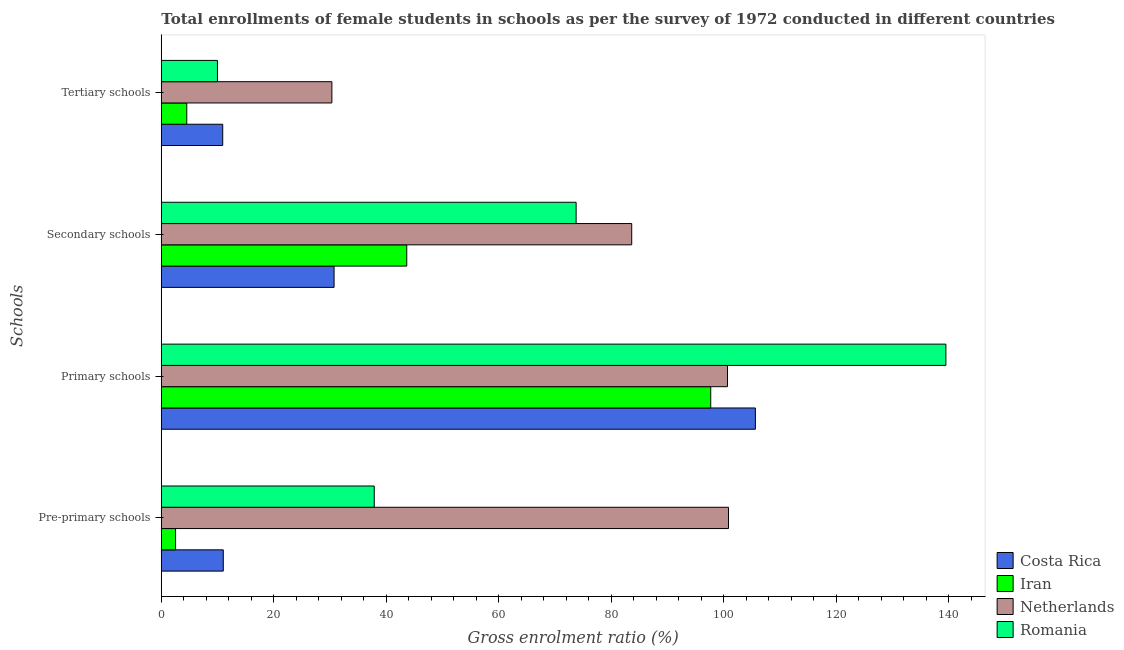How many groups of bars are there?
Your answer should be compact. 4. Are the number of bars per tick equal to the number of legend labels?
Offer a very short reply. Yes. How many bars are there on the 4th tick from the bottom?
Keep it short and to the point. 4. What is the label of the 2nd group of bars from the top?
Make the answer very short. Secondary schools. What is the gross enrolment ratio(female) in pre-primary schools in Romania?
Offer a terse response. 37.86. Across all countries, what is the maximum gross enrolment ratio(female) in tertiary schools?
Offer a terse response. 30.33. Across all countries, what is the minimum gross enrolment ratio(female) in tertiary schools?
Provide a succinct answer. 4.53. In which country was the gross enrolment ratio(female) in secondary schools maximum?
Keep it short and to the point. Netherlands. In which country was the gross enrolment ratio(female) in tertiary schools minimum?
Your answer should be very brief. Iran. What is the total gross enrolment ratio(female) in tertiary schools in the graph?
Your response must be concise. 55.75. What is the difference between the gross enrolment ratio(female) in tertiary schools in Romania and that in Iran?
Ensure brevity in your answer.  5.46. What is the difference between the gross enrolment ratio(female) in primary schools in Romania and the gross enrolment ratio(female) in secondary schools in Netherlands?
Your answer should be compact. 55.86. What is the average gross enrolment ratio(female) in pre-primary schools per country?
Your answer should be compact. 38.06. What is the difference between the gross enrolment ratio(female) in secondary schools and gross enrolment ratio(female) in tertiary schools in Iran?
Offer a very short reply. 39.11. In how many countries, is the gross enrolment ratio(female) in primary schools greater than 112 %?
Offer a very short reply. 1. What is the ratio of the gross enrolment ratio(female) in secondary schools in Romania to that in Costa Rica?
Provide a succinct answer. 2.4. Is the gross enrolment ratio(female) in primary schools in Iran less than that in Romania?
Provide a short and direct response. Yes. Is the difference between the gross enrolment ratio(female) in pre-primary schools in Costa Rica and Romania greater than the difference between the gross enrolment ratio(female) in primary schools in Costa Rica and Romania?
Offer a terse response. Yes. What is the difference between the highest and the second highest gross enrolment ratio(female) in primary schools?
Your response must be concise. 33.87. What is the difference between the highest and the lowest gross enrolment ratio(female) in primary schools?
Offer a very short reply. 41.81. Is the sum of the gross enrolment ratio(female) in secondary schools in Costa Rica and Romania greater than the maximum gross enrolment ratio(female) in tertiary schools across all countries?
Offer a very short reply. Yes. Is it the case that in every country, the sum of the gross enrolment ratio(female) in tertiary schools and gross enrolment ratio(female) in pre-primary schools is greater than the sum of gross enrolment ratio(female) in secondary schools and gross enrolment ratio(female) in primary schools?
Keep it short and to the point. No. Is it the case that in every country, the sum of the gross enrolment ratio(female) in pre-primary schools and gross enrolment ratio(female) in primary schools is greater than the gross enrolment ratio(female) in secondary schools?
Your response must be concise. Yes. Are all the bars in the graph horizontal?
Provide a succinct answer. Yes. What is the difference between two consecutive major ticks on the X-axis?
Your answer should be very brief. 20. Does the graph contain grids?
Your response must be concise. No. Where does the legend appear in the graph?
Offer a very short reply. Bottom right. What is the title of the graph?
Offer a terse response. Total enrollments of female students in schools as per the survey of 1972 conducted in different countries. What is the label or title of the Y-axis?
Your response must be concise. Schools. What is the Gross enrolment ratio (%) in Costa Rica in Pre-primary schools?
Offer a terse response. 11.02. What is the Gross enrolment ratio (%) in Iran in Pre-primary schools?
Your answer should be very brief. 2.53. What is the Gross enrolment ratio (%) in Netherlands in Pre-primary schools?
Offer a very short reply. 100.85. What is the Gross enrolment ratio (%) of Romania in Pre-primary schools?
Ensure brevity in your answer.  37.86. What is the Gross enrolment ratio (%) of Costa Rica in Primary schools?
Your response must be concise. 105.63. What is the Gross enrolment ratio (%) of Iran in Primary schools?
Your response must be concise. 97.69. What is the Gross enrolment ratio (%) of Netherlands in Primary schools?
Keep it short and to the point. 100.67. What is the Gross enrolment ratio (%) in Romania in Primary schools?
Offer a terse response. 139.5. What is the Gross enrolment ratio (%) of Costa Rica in Secondary schools?
Keep it short and to the point. 30.72. What is the Gross enrolment ratio (%) in Iran in Secondary schools?
Provide a succinct answer. 43.64. What is the Gross enrolment ratio (%) of Netherlands in Secondary schools?
Keep it short and to the point. 83.64. What is the Gross enrolment ratio (%) of Romania in Secondary schools?
Your response must be concise. 73.75. What is the Gross enrolment ratio (%) in Costa Rica in Tertiary schools?
Your response must be concise. 10.92. What is the Gross enrolment ratio (%) in Iran in Tertiary schools?
Provide a short and direct response. 4.53. What is the Gross enrolment ratio (%) of Netherlands in Tertiary schools?
Provide a succinct answer. 30.33. What is the Gross enrolment ratio (%) of Romania in Tertiary schools?
Give a very brief answer. 9.98. Across all Schools, what is the maximum Gross enrolment ratio (%) of Costa Rica?
Offer a very short reply. 105.63. Across all Schools, what is the maximum Gross enrolment ratio (%) of Iran?
Ensure brevity in your answer.  97.69. Across all Schools, what is the maximum Gross enrolment ratio (%) in Netherlands?
Your answer should be very brief. 100.85. Across all Schools, what is the maximum Gross enrolment ratio (%) of Romania?
Provide a short and direct response. 139.5. Across all Schools, what is the minimum Gross enrolment ratio (%) in Costa Rica?
Give a very brief answer. 10.92. Across all Schools, what is the minimum Gross enrolment ratio (%) of Iran?
Provide a succinct answer. 2.53. Across all Schools, what is the minimum Gross enrolment ratio (%) in Netherlands?
Keep it short and to the point. 30.33. Across all Schools, what is the minimum Gross enrolment ratio (%) of Romania?
Your response must be concise. 9.98. What is the total Gross enrolment ratio (%) in Costa Rica in the graph?
Your response must be concise. 158.28. What is the total Gross enrolment ratio (%) in Iran in the graph?
Your response must be concise. 148.39. What is the total Gross enrolment ratio (%) of Netherlands in the graph?
Your answer should be very brief. 315.48. What is the total Gross enrolment ratio (%) of Romania in the graph?
Offer a very short reply. 261.09. What is the difference between the Gross enrolment ratio (%) in Costa Rica in Pre-primary schools and that in Primary schools?
Provide a short and direct response. -94.61. What is the difference between the Gross enrolment ratio (%) of Iran in Pre-primary schools and that in Primary schools?
Keep it short and to the point. -95.16. What is the difference between the Gross enrolment ratio (%) in Netherlands in Pre-primary schools and that in Primary schools?
Offer a terse response. 0.18. What is the difference between the Gross enrolment ratio (%) in Romania in Pre-primary schools and that in Primary schools?
Give a very brief answer. -101.64. What is the difference between the Gross enrolment ratio (%) in Costa Rica in Pre-primary schools and that in Secondary schools?
Keep it short and to the point. -19.7. What is the difference between the Gross enrolment ratio (%) in Iran in Pre-primary schools and that in Secondary schools?
Offer a terse response. -41.11. What is the difference between the Gross enrolment ratio (%) of Netherlands in Pre-primary schools and that in Secondary schools?
Your answer should be compact. 17.21. What is the difference between the Gross enrolment ratio (%) in Romania in Pre-primary schools and that in Secondary schools?
Keep it short and to the point. -35.89. What is the difference between the Gross enrolment ratio (%) in Costa Rica in Pre-primary schools and that in Tertiary schools?
Ensure brevity in your answer.  0.1. What is the difference between the Gross enrolment ratio (%) in Iran in Pre-primary schools and that in Tertiary schools?
Your answer should be very brief. -1.99. What is the difference between the Gross enrolment ratio (%) of Netherlands in Pre-primary schools and that in Tertiary schools?
Offer a very short reply. 70.52. What is the difference between the Gross enrolment ratio (%) of Romania in Pre-primary schools and that in Tertiary schools?
Provide a succinct answer. 27.88. What is the difference between the Gross enrolment ratio (%) in Costa Rica in Primary schools and that in Secondary schools?
Offer a terse response. 74.91. What is the difference between the Gross enrolment ratio (%) in Iran in Primary schools and that in Secondary schools?
Your response must be concise. 54.05. What is the difference between the Gross enrolment ratio (%) in Netherlands in Primary schools and that in Secondary schools?
Provide a short and direct response. 17.03. What is the difference between the Gross enrolment ratio (%) of Romania in Primary schools and that in Secondary schools?
Give a very brief answer. 65.75. What is the difference between the Gross enrolment ratio (%) in Costa Rica in Primary schools and that in Tertiary schools?
Provide a succinct answer. 94.71. What is the difference between the Gross enrolment ratio (%) in Iran in Primary schools and that in Tertiary schools?
Ensure brevity in your answer.  93.16. What is the difference between the Gross enrolment ratio (%) in Netherlands in Primary schools and that in Tertiary schools?
Your response must be concise. 70.34. What is the difference between the Gross enrolment ratio (%) in Romania in Primary schools and that in Tertiary schools?
Keep it short and to the point. 129.52. What is the difference between the Gross enrolment ratio (%) of Costa Rica in Secondary schools and that in Tertiary schools?
Provide a succinct answer. 19.8. What is the difference between the Gross enrolment ratio (%) in Iran in Secondary schools and that in Tertiary schools?
Give a very brief answer. 39.11. What is the difference between the Gross enrolment ratio (%) of Netherlands in Secondary schools and that in Tertiary schools?
Give a very brief answer. 53.31. What is the difference between the Gross enrolment ratio (%) of Romania in Secondary schools and that in Tertiary schools?
Make the answer very short. 63.77. What is the difference between the Gross enrolment ratio (%) in Costa Rica in Pre-primary schools and the Gross enrolment ratio (%) in Iran in Primary schools?
Ensure brevity in your answer.  -86.67. What is the difference between the Gross enrolment ratio (%) in Costa Rica in Pre-primary schools and the Gross enrolment ratio (%) in Netherlands in Primary schools?
Your response must be concise. -89.65. What is the difference between the Gross enrolment ratio (%) of Costa Rica in Pre-primary schools and the Gross enrolment ratio (%) of Romania in Primary schools?
Provide a succinct answer. -128.48. What is the difference between the Gross enrolment ratio (%) in Iran in Pre-primary schools and the Gross enrolment ratio (%) in Netherlands in Primary schools?
Keep it short and to the point. -98.14. What is the difference between the Gross enrolment ratio (%) of Iran in Pre-primary schools and the Gross enrolment ratio (%) of Romania in Primary schools?
Ensure brevity in your answer.  -136.97. What is the difference between the Gross enrolment ratio (%) in Netherlands in Pre-primary schools and the Gross enrolment ratio (%) in Romania in Primary schools?
Give a very brief answer. -38.65. What is the difference between the Gross enrolment ratio (%) in Costa Rica in Pre-primary schools and the Gross enrolment ratio (%) in Iran in Secondary schools?
Ensure brevity in your answer.  -32.62. What is the difference between the Gross enrolment ratio (%) of Costa Rica in Pre-primary schools and the Gross enrolment ratio (%) of Netherlands in Secondary schools?
Give a very brief answer. -72.62. What is the difference between the Gross enrolment ratio (%) of Costa Rica in Pre-primary schools and the Gross enrolment ratio (%) of Romania in Secondary schools?
Provide a succinct answer. -62.74. What is the difference between the Gross enrolment ratio (%) in Iran in Pre-primary schools and the Gross enrolment ratio (%) in Netherlands in Secondary schools?
Provide a succinct answer. -81.11. What is the difference between the Gross enrolment ratio (%) of Iran in Pre-primary schools and the Gross enrolment ratio (%) of Romania in Secondary schools?
Provide a succinct answer. -71.22. What is the difference between the Gross enrolment ratio (%) in Netherlands in Pre-primary schools and the Gross enrolment ratio (%) in Romania in Secondary schools?
Your answer should be compact. 27.09. What is the difference between the Gross enrolment ratio (%) in Costa Rica in Pre-primary schools and the Gross enrolment ratio (%) in Iran in Tertiary schools?
Offer a terse response. 6.49. What is the difference between the Gross enrolment ratio (%) in Costa Rica in Pre-primary schools and the Gross enrolment ratio (%) in Netherlands in Tertiary schools?
Provide a short and direct response. -19.31. What is the difference between the Gross enrolment ratio (%) in Costa Rica in Pre-primary schools and the Gross enrolment ratio (%) in Romania in Tertiary schools?
Keep it short and to the point. 1.04. What is the difference between the Gross enrolment ratio (%) of Iran in Pre-primary schools and the Gross enrolment ratio (%) of Netherlands in Tertiary schools?
Your answer should be very brief. -27.8. What is the difference between the Gross enrolment ratio (%) of Iran in Pre-primary schools and the Gross enrolment ratio (%) of Romania in Tertiary schools?
Offer a terse response. -7.45. What is the difference between the Gross enrolment ratio (%) in Netherlands in Pre-primary schools and the Gross enrolment ratio (%) in Romania in Tertiary schools?
Your answer should be compact. 90.86. What is the difference between the Gross enrolment ratio (%) in Costa Rica in Primary schools and the Gross enrolment ratio (%) in Iran in Secondary schools?
Your response must be concise. 61.99. What is the difference between the Gross enrolment ratio (%) of Costa Rica in Primary schools and the Gross enrolment ratio (%) of Netherlands in Secondary schools?
Make the answer very short. 21.99. What is the difference between the Gross enrolment ratio (%) in Costa Rica in Primary schools and the Gross enrolment ratio (%) in Romania in Secondary schools?
Provide a short and direct response. 31.87. What is the difference between the Gross enrolment ratio (%) in Iran in Primary schools and the Gross enrolment ratio (%) in Netherlands in Secondary schools?
Offer a terse response. 14.05. What is the difference between the Gross enrolment ratio (%) of Iran in Primary schools and the Gross enrolment ratio (%) of Romania in Secondary schools?
Your answer should be compact. 23.94. What is the difference between the Gross enrolment ratio (%) in Netherlands in Primary schools and the Gross enrolment ratio (%) in Romania in Secondary schools?
Provide a short and direct response. 26.91. What is the difference between the Gross enrolment ratio (%) of Costa Rica in Primary schools and the Gross enrolment ratio (%) of Iran in Tertiary schools?
Your response must be concise. 101.1. What is the difference between the Gross enrolment ratio (%) of Costa Rica in Primary schools and the Gross enrolment ratio (%) of Netherlands in Tertiary schools?
Your answer should be compact. 75.3. What is the difference between the Gross enrolment ratio (%) of Costa Rica in Primary schools and the Gross enrolment ratio (%) of Romania in Tertiary schools?
Your answer should be very brief. 95.65. What is the difference between the Gross enrolment ratio (%) of Iran in Primary schools and the Gross enrolment ratio (%) of Netherlands in Tertiary schools?
Give a very brief answer. 67.36. What is the difference between the Gross enrolment ratio (%) in Iran in Primary schools and the Gross enrolment ratio (%) in Romania in Tertiary schools?
Ensure brevity in your answer.  87.71. What is the difference between the Gross enrolment ratio (%) of Netherlands in Primary schools and the Gross enrolment ratio (%) of Romania in Tertiary schools?
Your response must be concise. 90.69. What is the difference between the Gross enrolment ratio (%) in Costa Rica in Secondary schools and the Gross enrolment ratio (%) in Iran in Tertiary schools?
Keep it short and to the point. 26.19. What is the difference between the Gross enrolment ratio (%) in Costa Rica in Secondary schools and the Gross enrolment ratio (%) in Netherlands in Tertiary schools?
Ensure brevity in your answer.  0.39. What is the difference between the Gross enrolment ratio (%) of Costa Rica in Secondary schools and the Gross enrolment ratio (%) of Romania in Tertiary schools?
Your answer should be very brief. 20.74. What is the difference between the Gross enrolment ratio (%) of Iran in Secondary schools and the Gross enrolment ratio (%) of Netherlands in Tertiary schools?
Offer a very short reply. 13.31. What is the difference between the Gross enrolment ratio (%) of Iran in Secondary schools and the Gross enrolment ratio (%) of Romania in Tertiary schools?
Your answer should be compact. 33.66. What is the difference between the Gross enrolment ratio (%) in Netherlands in Secondary schools and the Gross enrolment ratio (%) in Romania in Tertiary schools?
Your answer should be very brief. 73.66. What is the average Gross enrolment ratio (%) in Costa Rica per Schools?
Provide a short and direct response. 39.57. What is the average Gross enrolment ratio (%) of Iran per Schools?
Offer a terse response. 37.1. What is the average Gross enrolment ratio (%) of Netherlands per Schools?
Provide a short and direct response. 78.87. What is the average Gross enrolment ratio (%) of Romania per Schools?
Provide a short and direct response. 65.27. What is the difference between the Gross enrolment ratio (%) of Costa Rica and Gross enrolment ratio (%) of Iran in Pre-primary schools?
Give a very brief answer. 8.49. What is the difference between the Gross enrolment ratio (%) of Costa Rica and Gross enrolment ratio (%) of Netherlands in Pre-primary schools?
Keep it short and to the point. -89.83. What is the difference between the Gross enrolment ratio (%) of Costa Rica and Gross enrolment ratio (%) of Romania in Pre-primary schools?
Offer a very short reply. -26.84. What is the difference between the Gross enrolment ratio (%) in Iran and Gross enrolment ratio (%) in Netherlands in Pre-primary schools?
Your answer should be very brief. -98.32. What is the difference between the Gross enrolment ratio (%) of Iran and Gross enrolment ratio (%) of Romania in Pre-primary schools?
Offer a terse response. -35.33. What is the difference between the Gross enrolment ratio (%) of Netherlands and Gross enrolment ratio (%) of Romania in Pre-primary schools?
Your response must be concise. 62.99. What is the difference between the Gross enrolment ratio (%) in Costa Rica and Gross enrolment ratio (%) in Iran in Primary schools?
Make the answer very short. 7.94. What is the difference between the Gross enrolment ratio (%) in Costa Rica and Gross enrolment ratio (%) in Netherlands in Primary schools?
Make the answer very short. 4.96. What is the difference between the Gross enrolment ratio (%) in Costa Rica and Gross enrolment ratio (%) in Romania in Primary schools?
Offer a terse response. -33.87. What is the difference between the Gross enrolment ratio (%) of Iran and Gross enrolment ratio (%) of Netherlands in Primary schools?
Provide a succinct answer. -2.98. What is the difference between the Gross enrolment ratio (%) in Iran and Gross enrolment ratio (%) in Romania in Primary schools?
Your response must be concise. -41.81. What is the difference between the Gross enrolment ratio (%) in Netherlands and Gross enrolment ratio (%) in Romania in Primary schools?
Make the answer very short. -38.83. What is the difference between the Gross enrolment ratio (%) of Costa Rica and Gross enrolment ratio (%) of Iran in Secondary schools?
Provide a succinct answer. -12.92. What is the difference between the Gross enrolment ratio (%) in Costa Rica and Gross enrolment ratio (%) in Netherlands in Secondary schools?
Keep it short and to the point. -52.92. What is the difference between the Gross enrolment ratio (%) in Costa Rica and Gross enrolment ratio (%) in Romania in Secondary schools?
Offer a very short reply. -43.04. What is the difference between the Gross enrolment ratio (%) of Iran and Gross enrolment ratio (%) of Romania in Secondary schools?
Offer a terse response. -30.11. What is the difference between the Gross enrolment ratio (%) of Netherlands and Gross enrolment ratio (%) of Romania in Secondary schools?
Ensure brevity in your answer.  9.89. What is the difference between the Gross enrolment ratio (%) in Costa Rica and Gross enrolment ratio (%) in Iran in Tertiary schools?
Provide a short and direct response. 6.39. What is the difference between the Gross enrolment ratio (%) in Costa Rica and Gross enrolment ratio (%) in Netherlands in Tertiary schools?
Ensure brevity in your answer.  -19.41. What is the difference between the Gross enrolment ratio (%) of Costa Rica and Gross enrolment ratio (%) of Romania in Tertiary schools?
Give a very brief answer. 0.94. What is the difference between the Gross enrolment ratio (%) of Iran and Gross enrolment ratio (%) of Netherlands in Tertiary schools?
Provide a short and direct response. -25.8. What is the difference between the Gross enrolment ratio (%) of Iran and Gross enrolment ratio (%) of Romania in Tertiary schools?
Provide a succinct answer. -5.46. What is the difference between the Gross enrolment ratio (%) in Netherlands and Gross enrolment ratio (%) in Romania in Tertiary schools?
Your answer should be very brief. 20.34. What is the ratio of the Gross enrolment ratio (%) of Costa Rica in Pre-primary schools to that in Primary schools?
Offer a very short reply. 0.1. What is the ratio of the Gross enrolment ratio (%) in Iran in Pre-primary schools to that in Primary schools?
Provide a short and direct response. 0.03. What is the ratio of the Gross enrolment ratio (%) in Netherlands in Pre-primary schools to that in Primary schools?
Your answer should be very brief. 1. What is the ratio of the Gross enrolment ratio (%) of Romania in Pre-primary schools to that in Primary schools?
Keep it short and to the point. 0.27. What is the ratio of the Gross enrolment ratio (%) in Costa Rica in Pre-primary schools to that in Secondary schools?
Offer a terse response. 0.36. What is the ratio of the Gross enrolment ratio (%) of Iran in Pre-primary schools to that in Secondary schools?
Offer a very short reply. 0.06. What is the ratio of the Gross enrolment ratio (%) in Netherlands in Pre-primary schools to that in Secondary schools?
Give a very brief answer. 1.21. What is the ratio of the Gross enrolment ratio (%) of Romania in Pre-primary schools to that in Secondary schools?
Offer a terse response. 0.51. What is the ratio of the Gross enrolment ratio (%) of Costa Rica in Pre-primary schools to that in Tertiary schools?
Offer a very short reply. 1.01. What is the ratio of the Gross enrolment ratio (%) of Iran in Pre-primary schools to that in Tertiary schools?
Ensure brevity in your answer.  0.56. What is the ratio of the Gross enrolment ratio (%) of Netherlands in Pre-primary schools to that in Tertiary schools?
Your response must be concise. 3.33. What is the ratio of the Gross enrolment ratio (%) of Romania in Pre-primary schools to that in Tertiary schools?
Make the answer very short. 3.79. What is the ratio of the Gross enrolment ratio (%) of Costa Rica in Primary schools to that in Secondary schools?
Keep it short and to the point. 3.44. What is the ratio of the Gross enrolment ratio (%) of Iran in Primary schools to that in Secondary schools?
Your response must be concise. 2.24. What is the ratio of the Gross enrolment ratio (%) in Netherlands in Primary schools to that in Secondary schools?
Keep it short and to the point. 1.2. What is the ratio of the Gross enrolment ratio (%) in Romania in Primary schools to that in Secondary schools?
Provide a short and direct response. 1.89. What is the ratio of the Gross enrolment ratio (%) of Costa Rica in Primary schools to that in Tertiary schools?
Give a very brief answer. 9.67. What is the ratio of the Gross enrolment ratio (%) in Iran in Primary schools to that in Tertiary schools?
Ensure brevity in your answer.  21.59. What is the ratio of the Gross enrolment ratio (%) in Netherlands in Primary schools to that in Tertiary schools?
Offer a terse response. 3.32. What is the ratio of the Gross enrolment ratio (%) in Romania in Primary schools to that in Tertiary schools?
Provide a succinct answer. 13.98. What is the ratio of the Gross enrolment ratio (%) of Costa Rica in Secondary schools to that in Tertiary schools?
Your answer should be compact. 2.81. What is the ratio of the Gross enrolment ratio (%) in Iran in Secondary schools to that in Tertiary schools?
Your answer should be compact. 9.64. What is the ratio of the Gross enrolment ratio (%) of Netherlands in Secondary schools to that in Tertiary schools?
Offer a very short reply. 2.76. What is the ratio of the Gross enrolment ratio (%) in Romania in Secondary schools to that in Tertiary schools?
Your answer should be compact. 7.39. What is the difference between the highest and the second highest Gross enrolment ratio (%) of Costa Rica?
Offer a very short reply. 74.91. What is the difference between the highest and the second highest Gross enrolment ratio (%) in Iran?
Your response must be concise. 54.05. What is the difference between the highest and the second highest Gross enrolment ratio (%) in Netherlands?
Ensure brevity in your answer.  0.18. What is the difference between the highest and the second highest Gross enrolment ratio (%) in Romania?
Keep it short and to the point. 65.75. What is the difference between the highest and the lowest Gross enrolment ratio (%) in Costa Rica?
Your answer should be compact. 94.71. What is the difference between the highest and the lowest Gross enrolment ratio (%) in Iran?
Your response must be concise. 95.16. What is the difference between the highest and the lowest Gross enrolment ratio (%) in Netherlands?
Ensure brevity in your answer.  70.52. What is the difference between the highest and the lowest Gross enrolment ratio (%) of Romania?
Give a very brief answer. 129.52. 